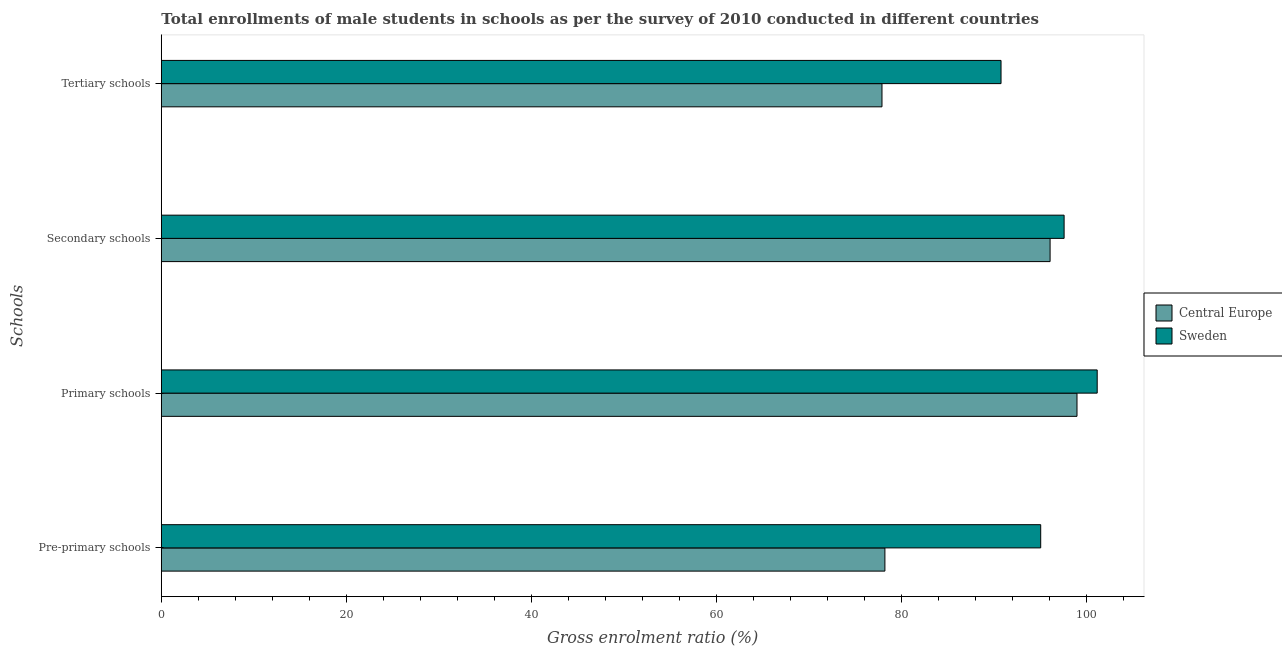How many different coloured bars are there?
Give a very brief answer. 2. Are the number of bars per tick equal to the number of legend labels?
Your answer should be very brief. Yes. How many bars are there on the 3rd tick from the top?
Make the answer very short. 2. How many bars are there on the 2nd tick from the bottom?
Ensure brevity in your answer.  2. What is the label of the 4th group of bars from the top?
Offer a terse response. Pre-primary schools. What is the gross enrolment ratio(male) in pre-primary schools in Central Europe?
Keep it short and to the point. 78.24. Across all countries, what is the maximum gross enrolment ratio(male) in primary schools?
Your answer should be very brief. 101.19. Across all countries, what is the minimum gross enrolment ratio(male) in secondary schools?
Keep it short and to the point. 96.1. In which country was the gross enrolment ratio(male) in primary schools maximum?
Your response must be concise. Sweden. In which country was the gross enrolment ratio(male) in primary schools minimum?
Ensure brevity in your answer.  Central Europe. What is the total gross enrolment ratio(male) in primary schools in the graph?
Offer a very short reply. 200.2. What is the difference between the gross enrolment ratio(male) in pre-primary schools in Central Europe and that in Sweden?
Your answer should be very brief. -16.85. What is the difference between the gross enrolment ratio(male) in tertiary schools in Sweden and the gross enrolment ratio(male) in secondary schools in Central Europe?
Give a very brief answer. -5.3. What is the average gross enrolment ratio(male) in primary schools per country?
Provide a short and direct response. 100.1. What is the difference between the gross enrolment ratio(male) in pre-primary schools and gross enrolment ratio(male) in secondary schools in Central Europe?
Offer a terse response. -17.86. In how many countries, is the gross enrolment ratio(male) in primary schools greater than 16 %?
Keep it short and to the point. 2. What is the ratio of the gross enrolment ratio(male) in secondary schools in Central Europe to that in Sweden?
Give a very brief answer. 0.98. Is the gross enrolment ratio(male) in pre-primary schools in Central Europe less than that in Sweden?
Provide a short and direct response. Yes. Is the difference between the gross enrolment ratio(male) in tertiary schools in Central Europe and Sweden greater than the difference between the gross enrolment ratio(male) in pre-primary schools in Central Europe and Sweden?
Ensure brevity in your answer.  Yes. What is the difference between the highest and the second highest gross enrolment ratio(male) in pre-primary schools?
Give a very brief answer. 16.85. What is the difference between the highest and the lowest gross enrolment ratio(male) in secondary schools?
Make the answer very short. 1.52. Is the sum of the gross enrolment ratio(male) in primary schools in Central Europe and Sweden greater than the maximum gross enrolment ratio(male) in pre-primary schools across all countries?
Provide a short and direct response. Yes. Is it the case that in every country, the sum of the gross enrolment ratio(male) in primary schools and gross enrolment ratio(male) in secondary schools is greater than the sum of gross enrolment ratio(male) in pre-primary schools and gross enrolment ratio(male) in tertiary schools?
Make the answer very short. Yes. What does the 1st bar from the bottom in Secondary schools represents?
Make the answer very short. Central Europe. How many bars are there?
Your response must be concise. 8. How many countries are there in the graph?
Make the answer very short. 2. What is the difference between two consecutive major ticks on the X-axis?
Ensure brevity in your answer.  20. Where does the legend appear in the graph?
Your response must be concise. Center right. How many legend labels are there?
Provide a succinct answer. 2. What is the title of the graph?
Give a very brief answer. Total enrollments of male students in schools as per the survey of 2010 conducted in different countries. What is the label or title of the Y-axis?
Ensure brevity in your answer.  Schools. What is the Gross enrolment ratio (%) of Central Europe in Pre-primary schools?
Make the answer very short. 78.24. What is the Gross enrolment ratio (%) in Sweden in Pre-primary schools?
Ensure brevity in your answer.  95.08. What is the Gross enrolment ratio (%) in Central Europe in Primary schools?
Offer a very short reply. 99.01. What is the Gross enrolment ratio (%) in Sweden in Primary schools?
Your response must be concise. 101.19. What is the Gross enrolment ratio (%) in Central Europe in Secondary schools?
Your answer should be very brief. 96.1. What is the Gross enrolment ratio (%) of Sweden in Secondary schools?
Ensure brevity in your answer.  97.61. What is the Gross enrolment ratio (%) of Central Europe in Tertiary schools?
Provide a succinct answer. 77.92. What is the Gross enrolment ratio (%) of Sweden in Tertiary schools?
Ensure brevity in your answer.  90.79. Across all Schools, what is the maximum Gross enrolment ratio (%) in Central Europe?
Your answer should be compact. 99.01. Across all Schools, what is the maximum Gross enrolment ratio (%) of Sweden?
Your response must be concise. 101.19. Across all Schools, what is the minimum Gross enrolment ratio (%) of Central Europe?
Ensure brevity in your answer.  77.92. Across all Schools, what is the minimum Gross enrolment ratio (%) of Sweden?
Provide a short and direct response. 90.79. What is the total Gross enrolment ratio (%) in Central Europe in the graph?
Keep it short and to the point. 351.26. What is the total Gross enrolment ratio (%) in Sweden in the graph?
Offer a terse response. 384.67. What is the difference between the Gross enrolment ratio (%) of Central Europe in Pre-primary schools and that in Primary schools?
Offer a very short reply. -20.77. What is the difference between the Gross enrolment ratio (%) of Sweden in Pre-primary schools and that in Primary schools?
Ensure brevity in your answer.  -6.11. What is the difference between the Gross enrolment ratio (%) in Central Europe in Pre-primary schools and that in Secondary schools?
Ensure brevity in your answer.  -17.86. What is the difference between the Gross enrolment ratio (%) in Sweden in Pre-primary schools and that in Secondary schools?
Keep it short and to the point. -2.53. What is the difference between the Gross enrolment ratio (%) of Central Europe in Pre-primary schools and that in Tertiary schools?
Provide a succinct answer. 0.31. What is the difference between the Gross enrolment ratio (%) in Sweden in Pre-primary schools and that in Tertiary schools?
Keep it short and to the point. 4.29. What is the difference between the Gross enrolment ratio (%) in Central Europe in Primary schools and that in Secondary schools?
Your response must be concise. 2.91. What is the difference between the Gross enrolment ratio (%) of Sweden in Primary schools and that in Secondary schools?
Give a very brief answer. 3.58. What is the difference between the Gross enrolment ratio (%) in Central Europe in Primary schools and that in Tertiary schools?
Provide a succinct answer. 21.08. What is the difference between the Gross enrolment ratio (%) of Sweden in Primary schools and that in Tertiary schools?
Your response must be concise. 10.4. What is the difference between the Gross enrolment ratio (%) of Central Europe in Secondary schools and that in Tertiary schools?
Your answer should be compact. 18.17. What is the difference between the Gross enrolment ratio (%) in Sweden in Secondary schools and that in Tertiary schools?
Your answer should be very brief. 6.82. What is the difference between the Gross enrolment ratio (%) of Central Europe in Pre-primary schools and the Gross enrolment ratio (%) of Sweden in Primary schools?
Offer a terse response. -22.95. What is the difference between the Gross enrolment ratio (%) in Central Europe in Pre-primary schools and the Gross enrolment ratio (%) in Sweden in Secondary schools?
Provide a short and direct response. -19.38. What is the difference between the Gross enrolment ratio (%) of Central Europe in Pre-primary schools and the Gross enrolment ratio (%) of Sweden in Tertiary schools?
Give a very brief answer. -12.56. What is the difference between the Gross enrolment ratio (%) in Central Europe in Primary schools and the Gross enrolment ratio (%) in Sweden in Secondary schools?
Provide a short and direct response. 1.39. What is the difference between the Gross enrolment ratio (%) of Central Europe in Primary schools and the Gross enrolment ratio (%) of Sweden in Tertiary schools?
Make the answer very short. 8.21. What is the difference between the Gross enrolment ratio (%) in Central Europe in Secondary schools and the Gross enrolment ratio (%) in Sweden in Tertiary schools?
Keep it short and to the point. 5.3. What is the average Gross enrolment ratio (%) in Central Europe per Schools?
Offer a terse response. 87.81. What is the average Gross enrolment ratio (%) in Sweden per Schools?
Keep it short and to the point. 96.17. What is the difference between the Gross enrolment ratio (%) of Central Europe and Gross enrolment ratio (%) of Sweden in Pre-primary schools?
Provide a succinct answer. -16.84. What is the difference between the Gross enrolment ratio (%) of Central Europe and Gross enrolment ratio (%) of Sweden in Primary schools?
Give a very brief answer. -2.18. What is the difference between the Gross enrolment ratio (%) of Central Europe and Gross enrolment ratio (%) of Sweden in Secondary schools?
Your answer should be very brief. -1.52. What is the difference between the Gross enrolment ratio (%) in Central Europe and Gross enrolment ratio (%) in Sweden in Tertiary schools?
Your answer should be very brief. -12.87. What is the ratio of the Gross enrolment ratio (%) in Central Europe in Pre-primary schools to that in Primary schools?
Make the answer very short. 0.79. What is the ratio of the Gross enrolment ratio (%) of Sweden in Pre-primary schools to that in Primary schools?
Provide a short and direct response. 0.94. What is the ratio of the Gross enrolment ratio (%) in Central Europe in Pre-primary schools to that in Secondary schools?
Make the answer very short. 0.81. What is the ratio of the Gross enrolment ratio (%) in Sweden in Pre-primary schools to that in Secondary schools?
Your answer should be very brief. 0.97. What is the ratio of the Gross enrolment ratio (%) of Central Europe in Pre-primary schools to that in Tertiary schools?
Provide a succinct answer. 1. What is the ratio of the Gross enrolment ratio (%) of Sweden in Pre-primary schools to that in Tertiary schools?
Provide a succinct answer. 1.05. What is the ratio of the Gross enrolment ratio (%) in Central Europe in Primary schools to that in Secondary schools?
Make the answer very short. 1.03. What is the ratio of the Gross enrolment ratio (%) in Sweden in Primary schools to that in Secondary schools?
Make the answer very short. 1.04. What is the ratio of the Gross enrolment ratio (%) of Central Europe in Primary schools to that in Tertiary schools?
Offer a very short reply. 1.27. What is the ratio of the Gross enrolment ratio (%) in Sweden in Primary schools to that in Tertiary schools?
Your response must be concise. 1.11. What is the ratio of the Gross enrolment ratio (%) of Central Europe in Secondary schools to that in Tertiary schools?
Offer a very short reply. 1.23. What is the ratio of the Gross enrolment ratio (%) of Sweden in Secondary schools to that in Tertiary schools?
Make the answer very short. 1.08. What is the difference between the highest and the second highest Gross enrolment ratio (%) in Central Europe?
Offer a very short reply. 2.91. What is the difference between the highest and the second highest Gross enrolment ratio (%) in Sweden?
Your answer should be compact. 3.58. What is the difference between the highest and the lowest Gross enrolment ratio (%) of Central Europe?
Offer a terse response. 21.08. What is the difference between the highest and the lowest Gross enrolment ratio (%) in Sweden?
Your response must be concise. 10.4. 